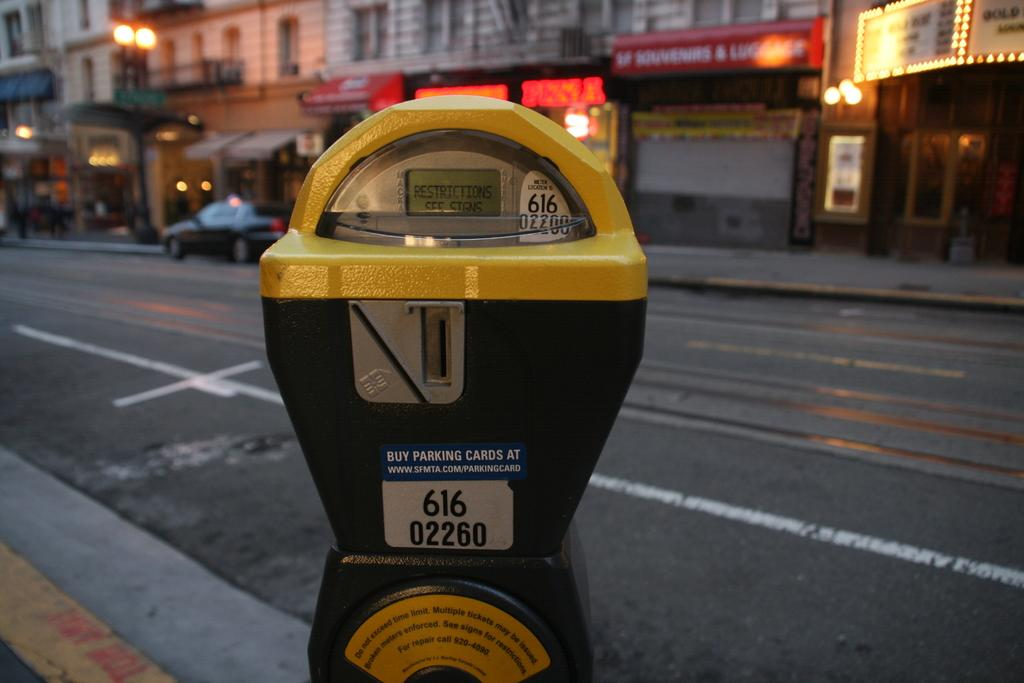<image>
Summarize the visual content of the image. A parking meter on a city street registered under the number 616 02260. 